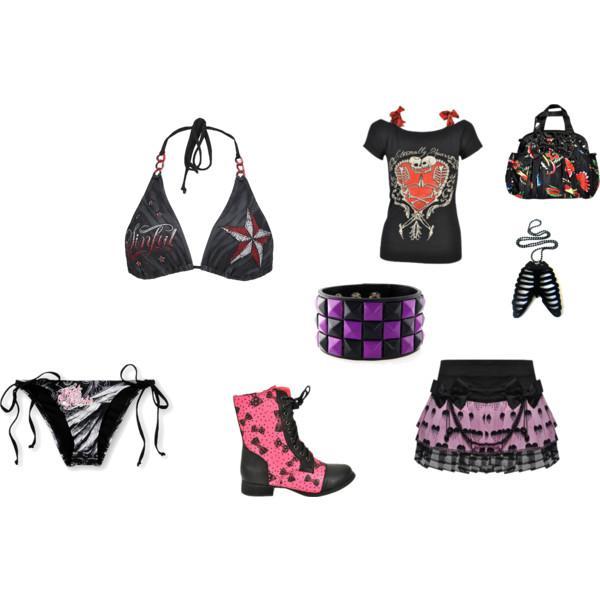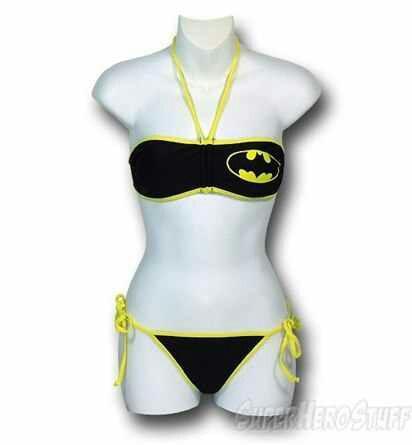The first image is the image on the left, the second image is the image on the right. Examine the images to the left and right. Is the description "At least one bikini bottom ties on with strings." accurate? Answer yes or no. Yes. 